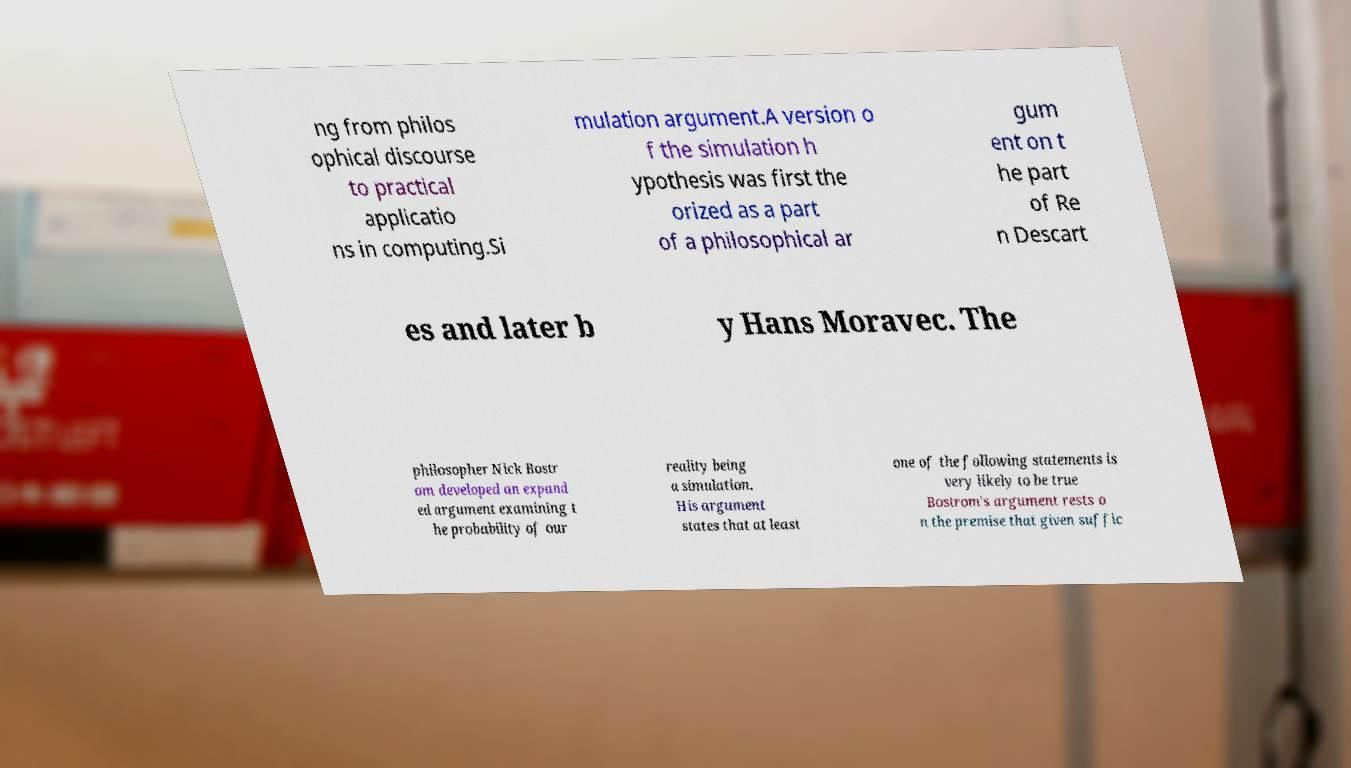Please identify and transcribe the text found in this image. ng from philos ophical discourse to practical applicatio ns in computing.Si mulation argument.A version o f the simulation h ypothesis was first the orized as a part of a philosophical ar gum ent on t he part of Re n Descart es and later b y Hans Moravec. The philosopher Nick Bostr om developed an expand ed argument examining t he probability of our reality being a simulation. His argument states that at least one of the following statements is very likely to be true Bostrom's argument rests o n the premise that given suffic 